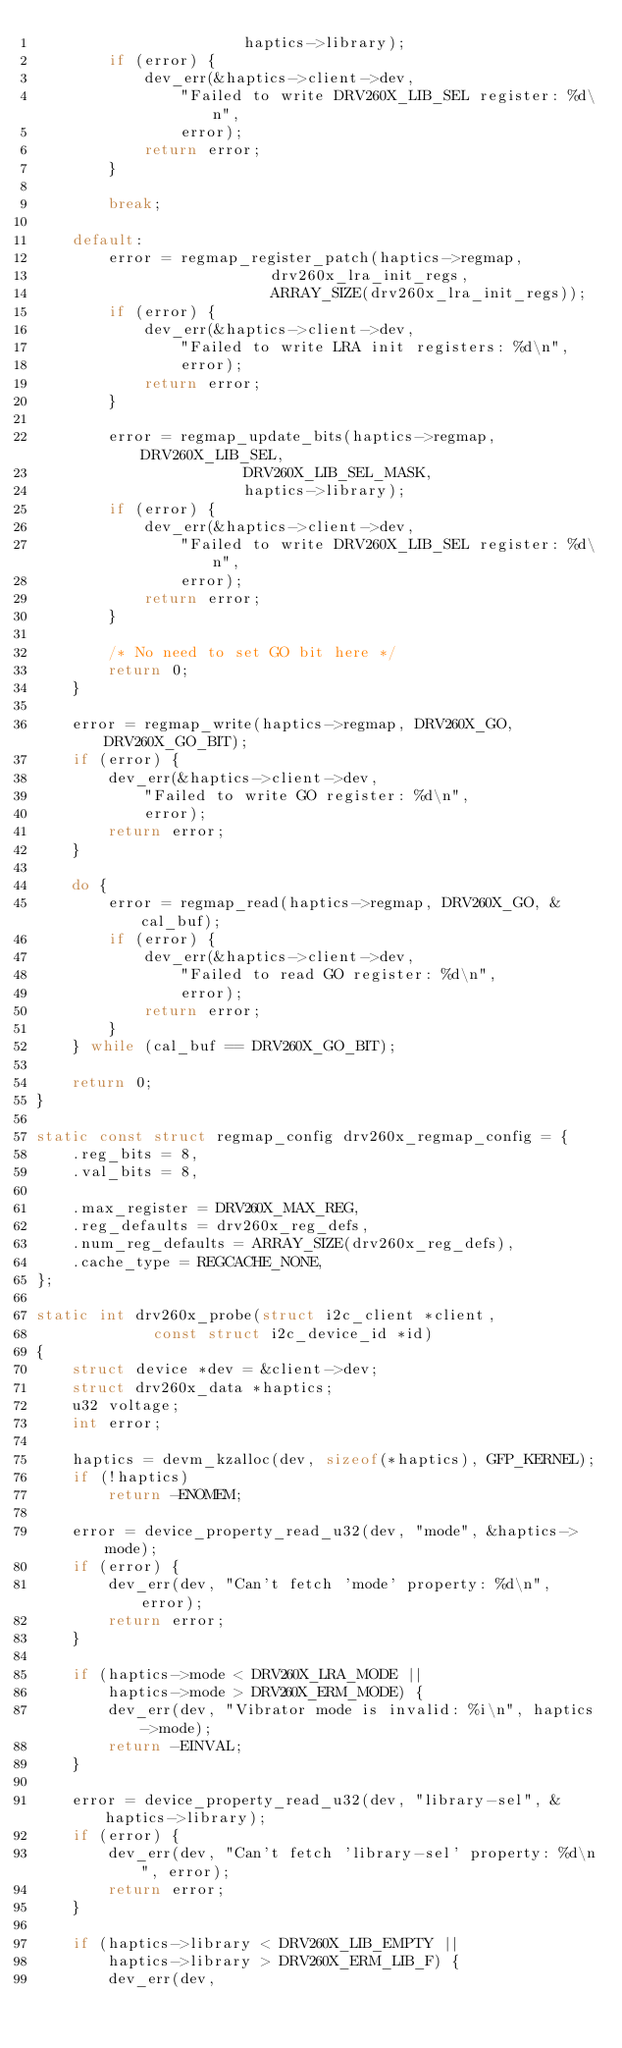Convert code to text. <code><loc_0><loc_0><loc_500><loc_500><_C_>					   haptics->library);
		if (error) {
			dev_err(&haptics->client->dev,
				"Failed to write DRV260X_LIB_SEL register: %d\n",
				error);
			return error;
		}

		break;

	default:
		error = regmap_register_patch(haptics->regmap,
					      drv260x_lra_init_regs,
					      ARRAY_SIZE(drv260x_lra_init_regs));
		if (error) {
			dev_err(&haptics->client->dev,
				"Failed to write LRA init registers: %d\n",
				error);
			return error;
		}

		error = regmap_update_bits(haptics->regmap, DRV260X_LIB_SEL,
					   DRV260X_LIB_SEL_MASK,
					   haptics->library);
		if (error) {
			dev_err(&haptics->client->dev,
				"Failed to write DRV260X_LIB_SEL register: %d\n",
				error);
			return error;
		}

		/* No need to set GO bit here */
		return 0;
	}

	error = regmap_write(haptics->regmap, DRV260X_GO, DRV260X_GO_BIT);
	if (error) {
		dev_err(&haptics->client->dev,
			"Failed to write GO register: %d\n",
			error);
		return error;
	}

	do {
		error = regmap_read(haptics->regmap, DRV260X_GO, &cal_buf);
		if (error) {
			dev_err(&haptics->client->dev,
				"Failed to read GO register: %d\n",
				error);
			return error;
		}
	} while (cal_buf == DRV260X_GO_BIT);

	return 0;
}

static const struct regmap_config drv260x_regmap_config = {
	.reg_bits = 8,
	.val_bits = 8,

	.max_register = DRV260X_MAX_REG,
	.reg_defaults = drv260x_reg_defs,
	.num_reg_defaults = ARRAY_SIZE(drv260x_reg_defs),
	.cache_type = REGCACHE_NONE,
};

static int drv260x_probe(struct i2c_client *client,
			 const struct i2c_device_id *id)
{
	struct device *dev = &client->dev;
	struct drv260x_data *haptics;
	u32 voltage;
	int error;

	haptics = devm_kzalloc(dev, sizeof(*haptics), GFP_KERNEL);
	if (!haptics)
		return -ENOMEM;

	error = device_property_read_u32(dev, "mode", &haptics->mode);
	if (error) {
		dev_err(dev, "Can't fetch 'mode' property: %d\n", error);
		return error;
	}

	if (haptics->mode < DRV260X_LRA_MODE ||
	    haptics->mode > DRV260X_ERM_MODE) {
		dev_err(dev, "Vibrator mode is invalid: %i\n", haptics->mode);
		return -EINVAL;
	}

	error = device_property_read_u32(dev, "library-sel", &haptics->library);
	if (error) {
		dev_err(dev, "Can't fetch 'library-sel' property: %d\n", error);
		return error;
	}

	if (haptics->library < DRV260X_LIB_EMPTY ||
	    haptics->library > DRV260X_ERM_LIB_F) {
		dev_err(dev,</code> 